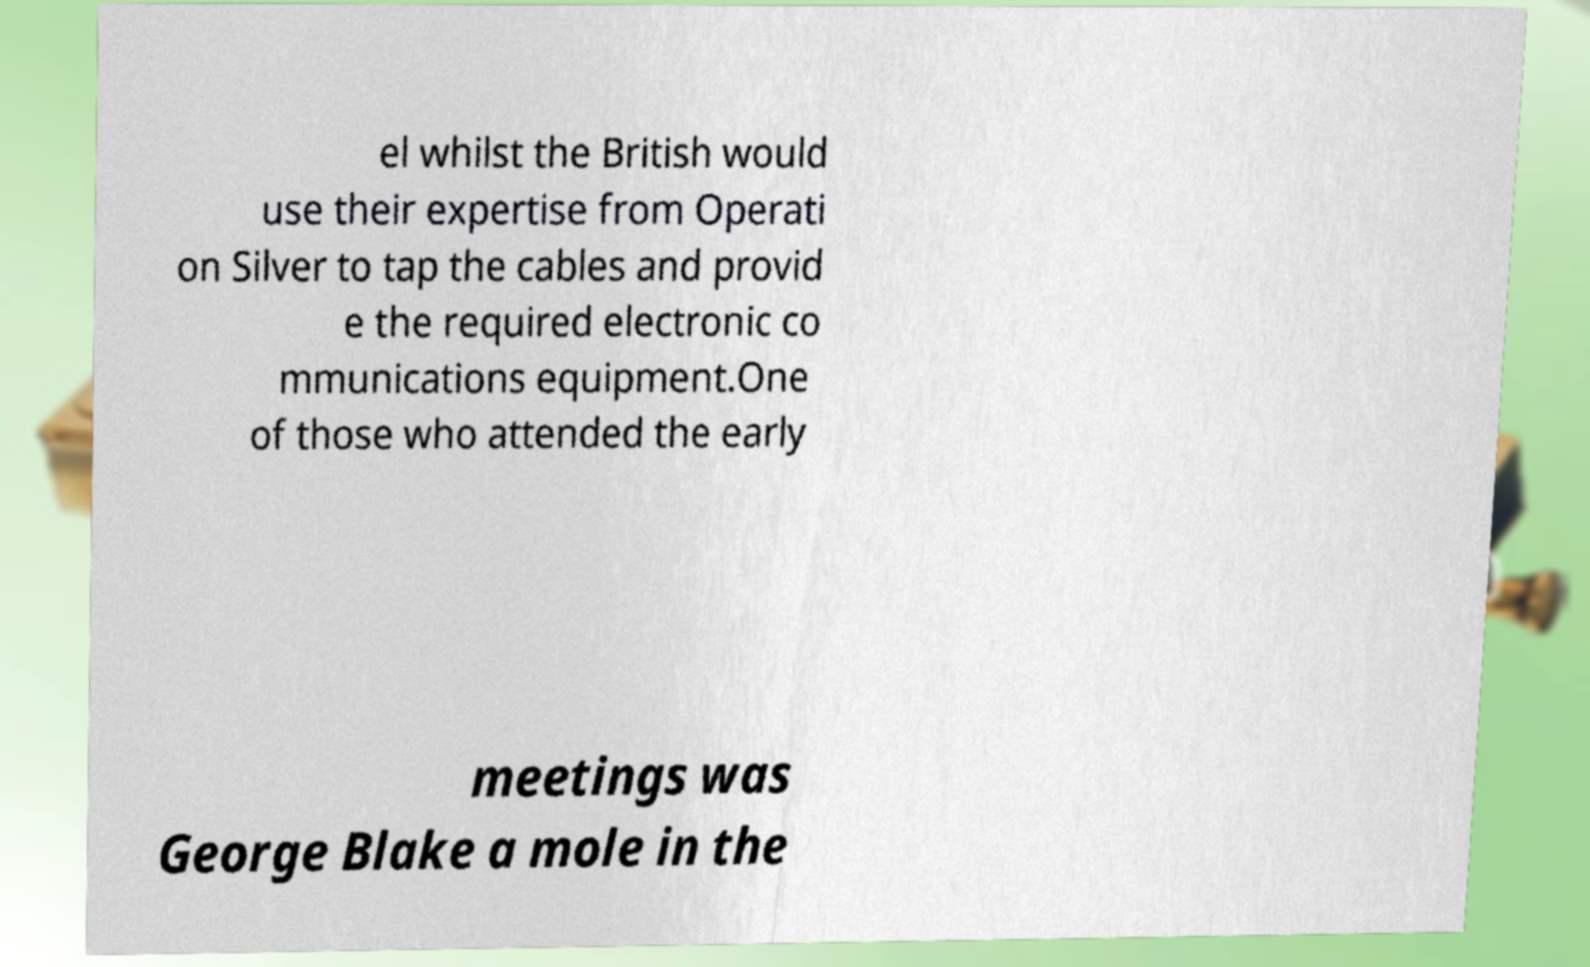There's text embedded in this image that I need extracted. Can you transcribe it verbatim? el whilst the British would use their expertise from Operati on Silver to tap the cables and provid e the required electronic co mmunications equipment.One of those who attended the early meetings was George Blake a mole in the 